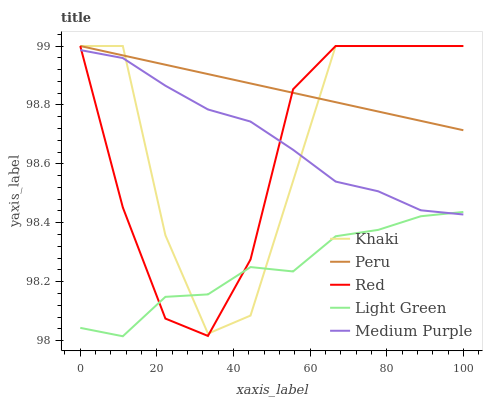Does Light Green have the minimum area under the curve?
Answer yes or no. Yes. Does Peru have the maximum area under the curve?
Answer yes or no. Yes. Does Medium Purple have the minimum area under the curve?
Answer yes or no. No. Does Medium Purple have the maximum area under the curve?
Answer yes or no. No. Is Peru the smoothest?
Answer yes or no. Yes. Is Khaki the roughest?
Answer yes or no. Yes. Is Medium Purple the smoothest?
Answer yes or no. No. Is Medium Purple the roughest?
Answer yes or no. No. Does Light Green have the lowest value?
Answer yes or no. Yes. Does Medium Purple have the lowest value?
Answer yes or no. No. Does Peru have the highest value?
Answer yes or no. Yes. Does Medium Purple have the highest value?
Answer yes or no. No. Is Light Green less than Peru?
Answer yes or no. Yes. Is Peru greater than Light Green?
Answer yes or no. Yes. Does Medium Purple intersect Light Green?
Answer yes or no. Yes. Is Medium Purple less than Light Green?
Answer yes or no. No. Is Medium Purple greater than Light Green?
Answer yes or no. No. Does Light Green intersect Peru?
Answer yes or no. No. 